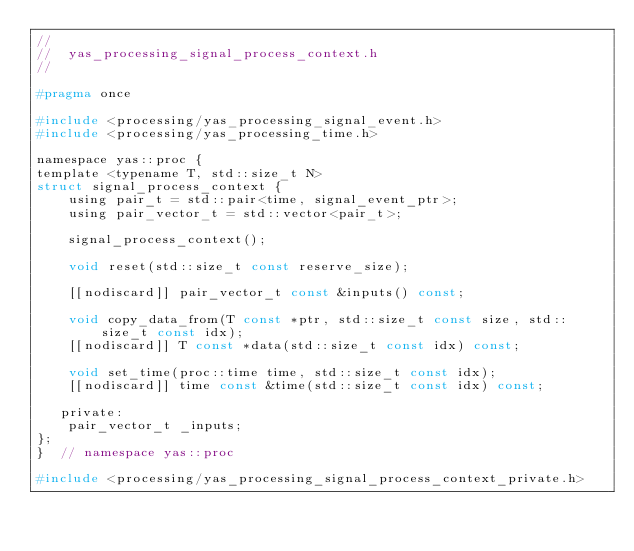<code> <loc_0><loc_0><loc_500><loc_500><_C_>//
//  yas_processing_signal_process_context.h
//

#pragma once

#include <processing/yas_processing_signal_event.h>
#include <processing/yas_processing_time.h>

namespace yas::proc {
template <typename T, std::size_t N>
struct signal_process_context {
    using pair_t = std::pair<time, signal_event_ptr>;
    using pair_vector_t = std::vector<pair_t>;

    signal_process_context();

    void reset(std::size_t const reserve_size);

    [[nodiscard]] pair_vector_t const &inputs() const;

    void copy_data_from(T const *ptr, std::size_t const size, std::size_t const idx);
    [[nodiscard]] T const *data(std::size_t const idx) const;

    void set_time(proc::time time, std::size_t const idx);
    [[nodiscard]] time const &time(std::size_t const idx) const;

   private:
    pair_vector_t _inputs;
};
}  // namespace yas::proc

#include <processing/yas_processing_signal_process_context_private.h>
</code> 